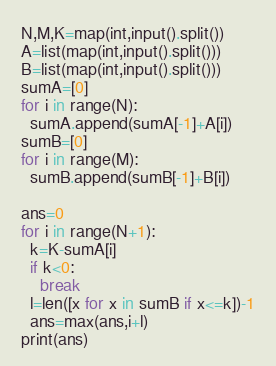<code> <loc_0><loc_0><loc_500><loc_500><_Python_>N,M,K=map(int,input().split())
A=list(map(int,input().split()))
B=list(map(int,input().split()))
sumA=[0]
for i in range(N):
  sumA.append(sumA[-1]+A[i])
sumB=[0]
for i in range(M):
  sumB.append(sumB[-1]+B[i])

ans=0
for i in range(N+1):
  k=K-sumA[i]
  if k<0:
    break
  l=len([x for x in sumB if x<=k])-1
  ans=max(ans,i+l)
print(ans)</code> 